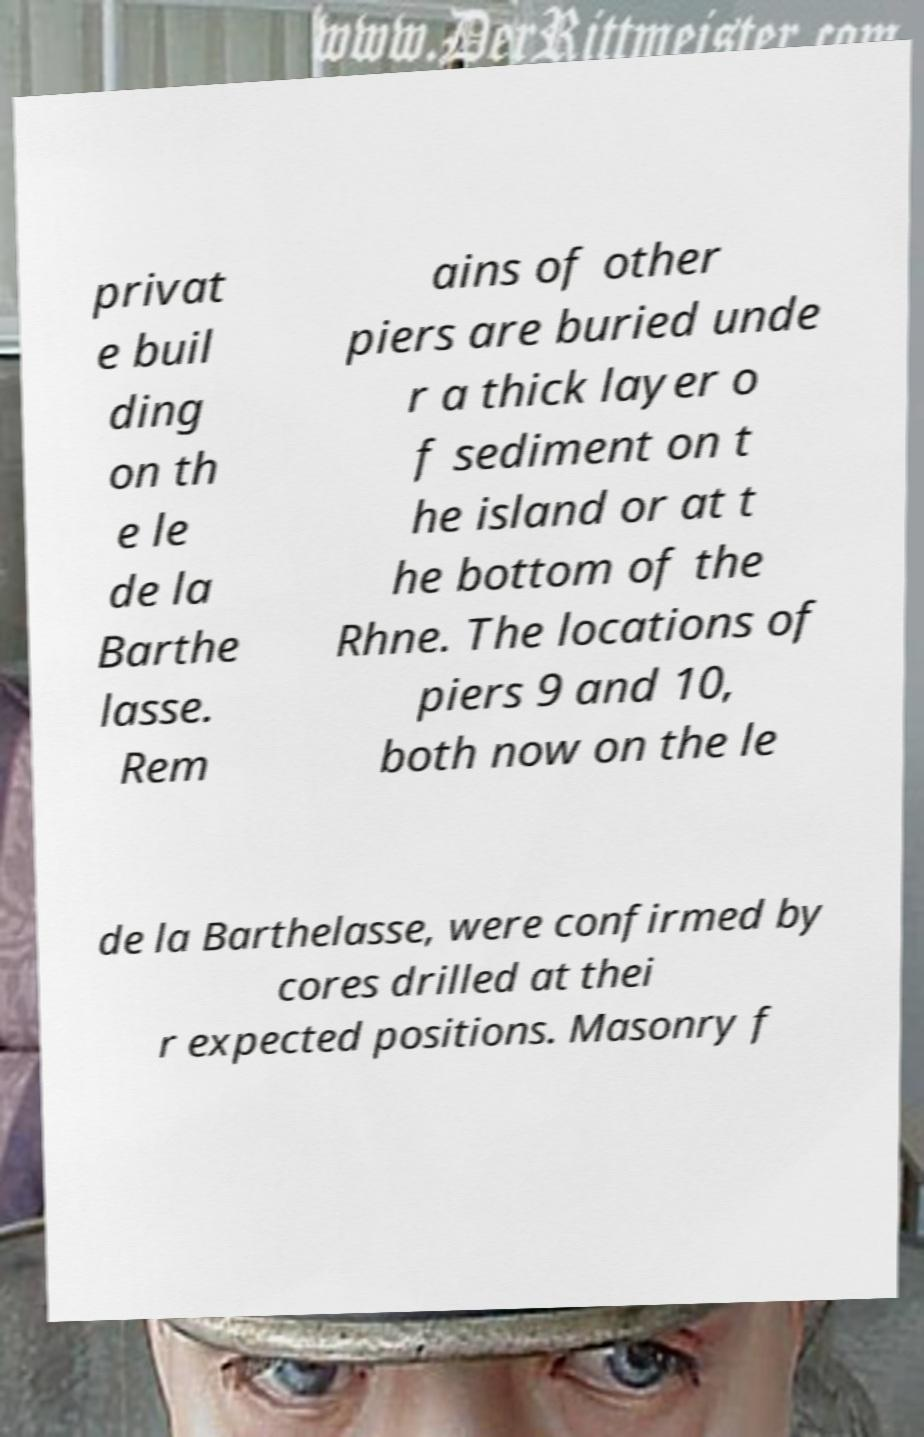There's text embedded in this image that I need extracted. Can you transcribe it verbatim? privat e buil ding on th e le de la Barthe lasse. Rem ains of other piers are buried unde r a thick layer o f sediment on t he island or at t he bottom of the Rhne. The locations of piers 9 and 10, both now on the le de la Barthelasse, were confirmed by cores drilled at thei r expected positions. Masonry f 